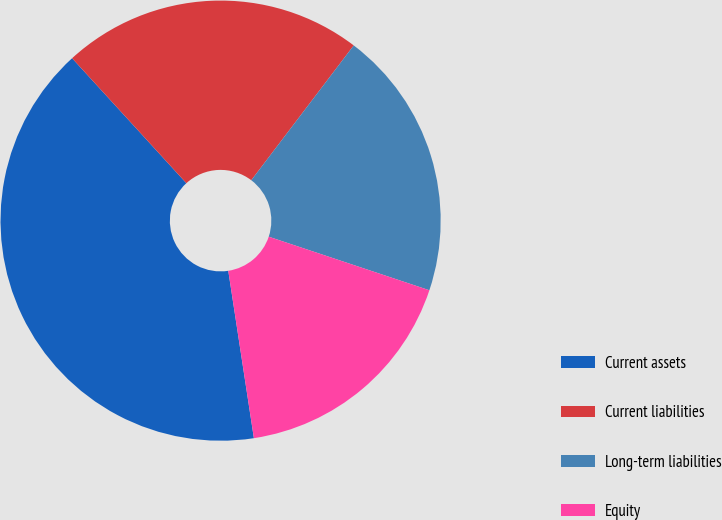Convert chart to OTSL. <chart><loc_0><loc_0><loc_500><loc_500><pie_chart><fcel>Current assets<fcel>Current liabilities<fcel>Long-term liabilities<fcel>Equity<nl><fcel>40.63%<fcel>22.13%<fcel>19.78%<fcel>17.46%<nl></chart> 